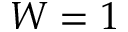Convert formula to latex. <formula><loc_0><loc_0><loc_500><loc_500>W = 1</formula> 